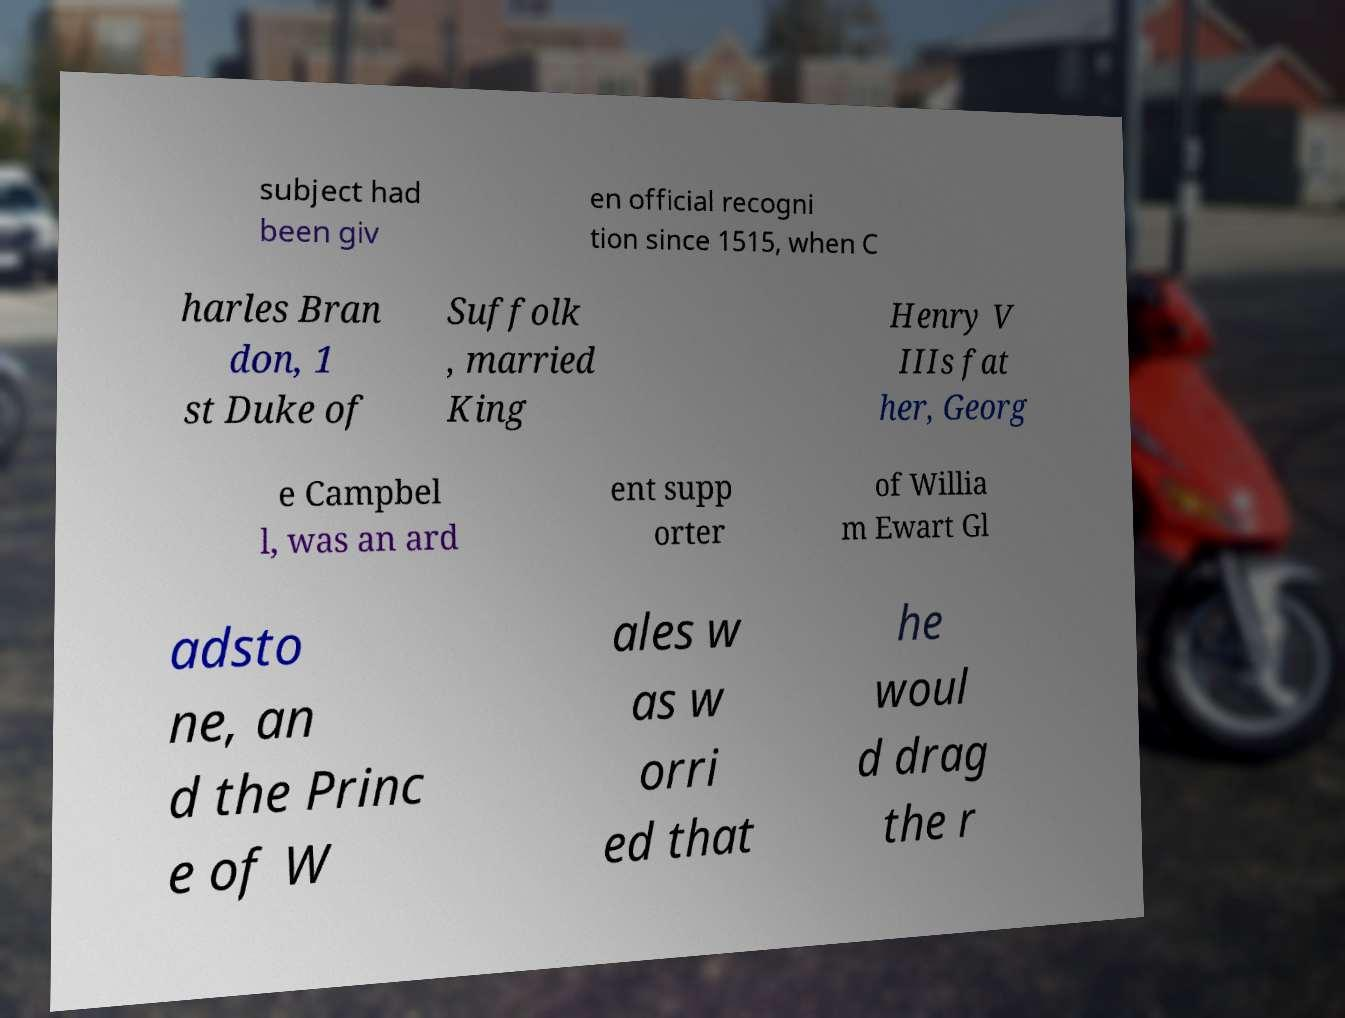Please identify and transcribe the text found in this image. subject had been giv en official recogni tion since 1515, when C harles Bran don, 1 st Duke of Suffolk , married King Henry V IIIs fat her, Georg e Campbel l, was an ard ent supp orter of Willia m Ewart Gl adsto ne, an d the Princ e of W ales w as w orri ed that he woul d drag the r 